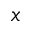Convert formula to latex. <formula><loc_0><loc_0><loc_500><loc_500>x</formula> 